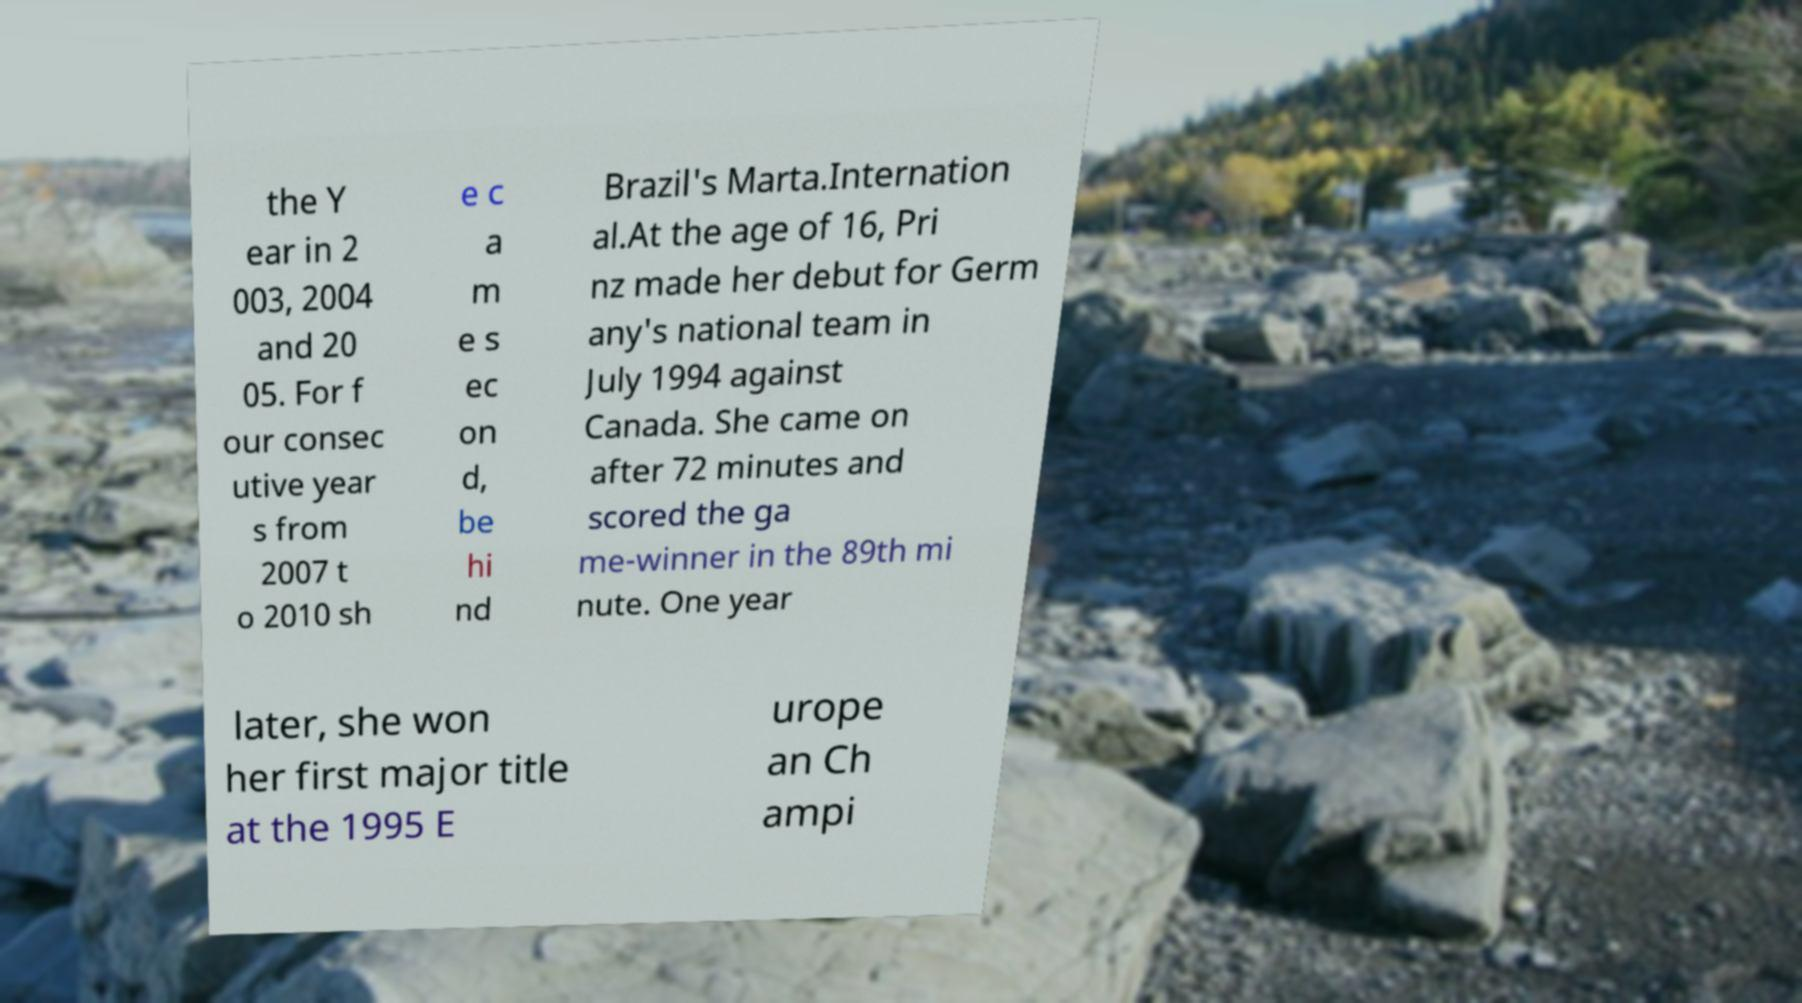Could you extract and type out the text from this image? the Y ear in 2 003, 2004 and 20 05. For f our consec utive year s from 2007 t o 2010 sh e c a m e s ec on d, be hi nd Brazil's Marta.Internation al.At the age of 16, Pri nz made her debut for Germ any's national team in July 1994 against Canada. She came on after 72 minutes and scored the ga me-winner in the 89th mi nute. One year later, she won her first major title at the 1995 E urope an Ch ampi 